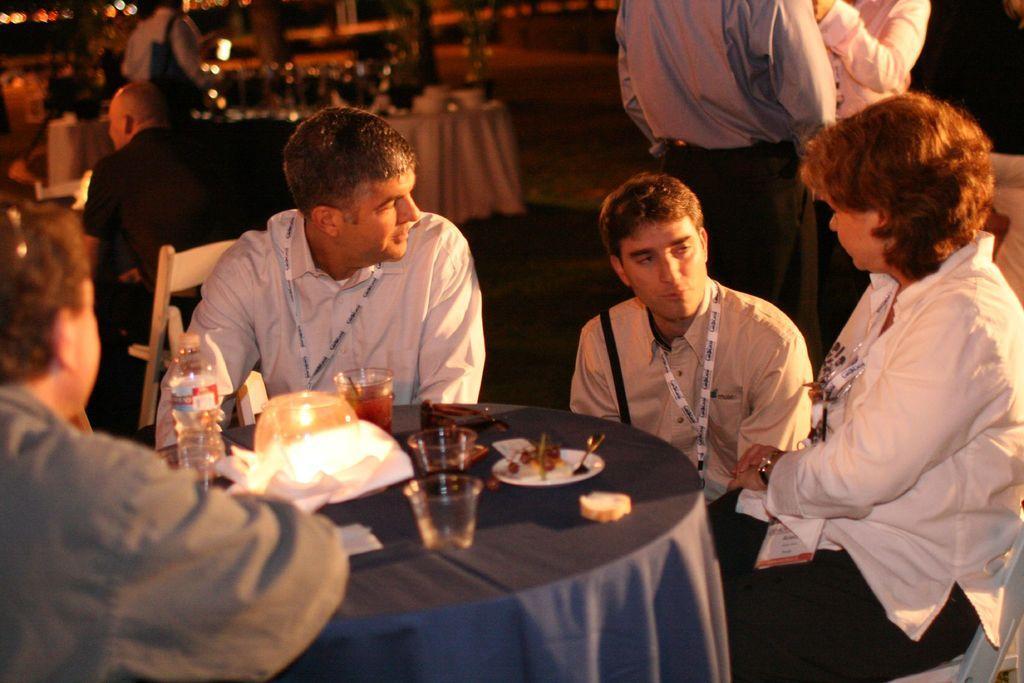Describe this image in one or two sentences. In this picture there are three men and a woman sitting on the chair. There is a bottle, cap, candle glass, spoon , food, plate on the table. There is a light and few other people sitting at the background. There are two men standing to the right. 